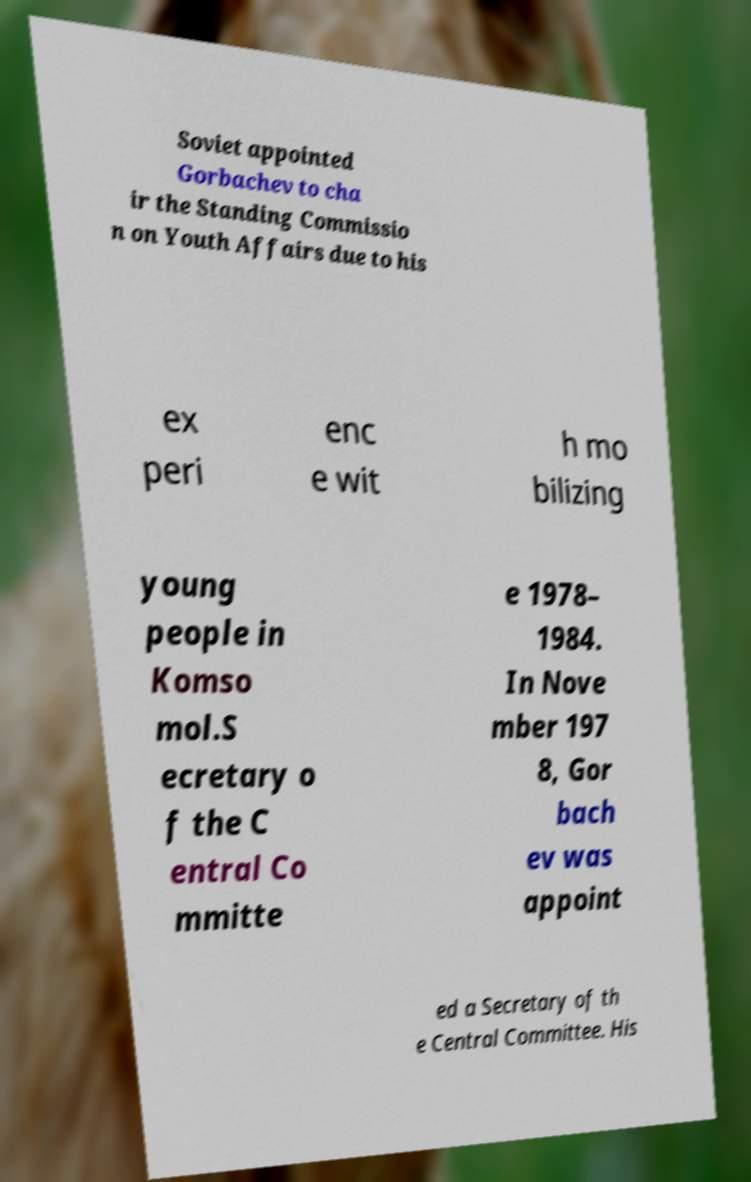For documentation purposes, I need the text within this image transcribed. Could you provide that? Soviet appointed Gorbachev to cha ir the Standing Commissio n on Youth Affairs due to his ex peri enc e wit h mo bilizing young people in Komso mol.S ecretary o f the C entral Co mmitte e 1978– 1984. In Nove mber 197 8, Gor bach ev was appoint ed a Secretary of th e Central Committee. His 